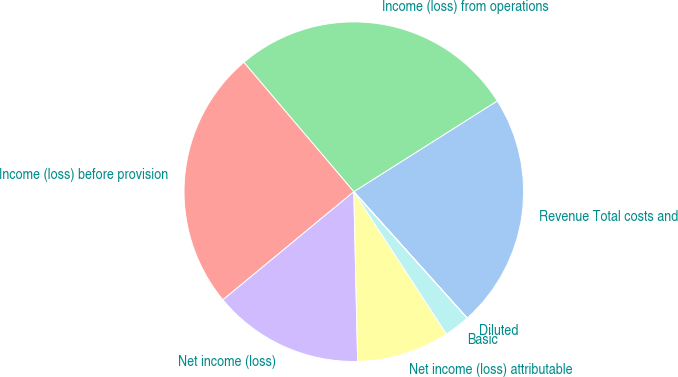<chart> <loc_0><loc_0><loc_500><loc_500><pie_chart><fcel>Revenue Total costs and<fcel>Income (loss) from operations<fcel>Income (loss) before provision<fcel>Net income (loss)<fcel>Net income (loss) attributable<fcel>Basic<fcel>Diluted<nl><fcel>22.34%<fcel>27.23%<fcel>24.78%<fcel>14.37%<fcel>8.82%<fcel>2.45%<fcel>0.01%<nl></chart> 